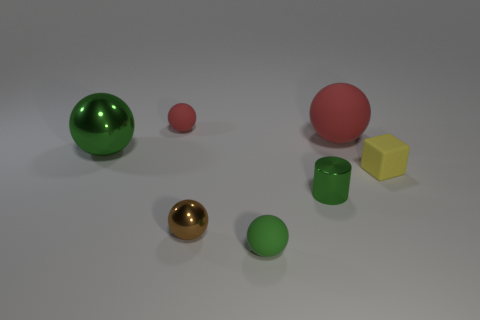Subtract all green balls. How many were subtracted if there are1green balls left? 1 Subtract all tiny metal spheres. How many spheres are left? 4 Subtract all gray spheres. Subtract all red cylinders. How many spheres are left? 5 Add 2 large red rubber things. How many objects exist? 9 Subtract all cubes. How many objects are left? 6 Subtract all green balls. Subtract all small red rubber objects. How many objects are left? 4 Add 5 rubber objects. How many rubber objects are left? 9 Add 3 yellow matte blocks. How many yellow matte blocks exist? 4 Subtract 0 blue cylinders. How many objects are left? 7 